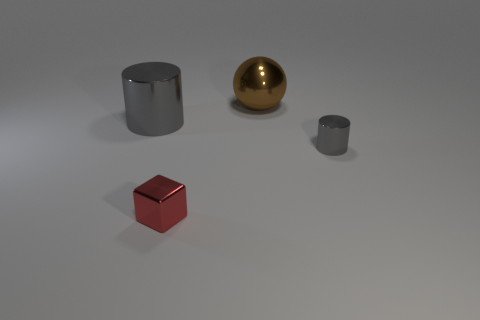Add 1 large green shiny cylinders. How many objects exist? 5 Subtract 1 cubes. How many cubes are left? 0 Subtract all cubes. Subtract all large things. How many objects are left? 1 Add 4 small red cubes. How many small red cubes are left? 5 Add 3 large objects. How many large objects exist? 5 Subtract 0 blue cubes. How many objects are left? 4 Subtract all cyan cubes. Subtract all blue cylinders. How many cubes are left? 1 